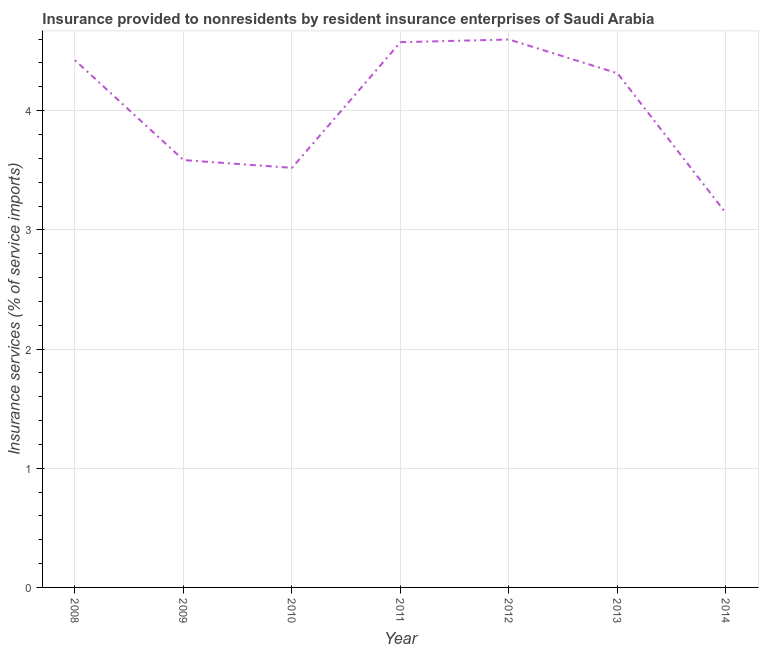What is the insurance and financial services in 2013?
Your answer should be compact. 4.31. Across all years, what is the maximum insurance and financial services?
Offer a very short reply. 4.6. Across all years, what is the minimum insurance and financial services?
Ensure brevity in your answer.  3.14. What is the sum of the insurance and financial services?
Offer a terse response. 28.16. What is the difference between the insurance and financial services in 2011 and 2013?
Your answer should be compact. 0.26. What is the average insurance and financial services per year?
Provide a short and direct response. 4.02. What is the median insurance and financial services?
Your response must be concise. 4.31. In how many years, is the insurance and financial services greater than 1.2 %?
Make the answer very short. 7. Do a majority of the years between 2011 and 2012 (inclusive) have insurance and financial services greater than 3.8 %?
Your answer should be compact. Yes. What is the ratio of the insurance and financial services in 2008 to that in 2009?
Offer a terse response. 1.23. Is the difference between the insurance and financial services in 2008 and 2011 greater than the difference between any two years?
Ensure brevity in your answer.  No. What is the difference between the highest and the second highest insurance and financial services?
Make the answer very short. 0.02. Is the sum of the insurance and financial services in 2011 and 2013 greater than the maximum insurance and financial services across all years?
Ensure brevity in your answer.  Yes. What is the difference between the highest and the lowest insurance and financial services?
Make the answer very short. 1.46. How many years are there in the graph?
Provide a succinct answer. 7. What is the difference between two consecutive major ticks on the Y-axis?
Ensure brevity in your answer.  1. What is the title of the graph?
Offer a very short reply. Insurance provided to nonresidents by resident insurance enterprises of Saudi Arabia. What is the label or title of the X-axis?
Give a very brief answer. Year. What is the label or title of the Y-axis?
Offer a very short reply. Insurance services (% of service imports). What is the Insurance services (% of service imports) in 2008?
Provide a short and direct response. 4.42. What is the Insurance services (% of service imports) in 2009?
Offer a very short reply. 3.59. What is the Insurance services (% of service imports) in 2010?
Keep it short and to the point. 3.52. What is the Insurance services (% of service imports) in 2011?
Offer a very short reply. 4.57. What is the Insurance services (% of service imports) of 2012?
Your response must be concise. 4.6. What is the Insurance services (% of service imports) in 2013?
Provide a succinct answer. 4.31. What is the Insurance services (% of service imports) in 2014?
Ensure brevity in your answer.  3.14. What is the difference between the Insurance services (% of service imports) in 2008 and 2009?
Provide a short and direct response. 0.84. What is the difference between the Insurance services (% of service imports) in 2008 and 2010?
Provide a short and direct response. 0.9. What is the difference between the Insurance services (% of service imports) in 2008 and 2011?
Your answer should be very brief. -0.15. What is the difference between the Insurance services (% of service imports) in 2008 and 2012?
Provide a short and direct response. -0.17. What is the difference between the Insurance services (% of service imports) in 2008 and 2013?
Provide a short and direct response. 0.11. What is the difference between the Insurance services (% of service imports) in 2008 and 2014?
Keep it short and to the point. 1.28. What is the difference between the Insurance services (% of service imports) in 2009 and 2010?
Provide a succinct answer. 0.07. What is the difference between the Insurance services (% of service imports) in 2009 and 2011?
Make the answer very short. -0.99. What is the difference between the Insurance services (% of service imports) in 2009 and 2012?
Offer a very short reply. -1.01. What is the difference between the Insurance services (% of service imports) in 2009 and 2013?
Your answer should be very brief. -0.73. What is the difference between the Insurance services (% of service imports) in 2009 and 2014?
Provide a succinct answer. 0.45. What is the difference between the Insurance services (% of service imports) in 2010 and 2011?
Provide a succinct answer. -1.05. What is the difference between the Insurance services (% of service imports) in 2010 and 2012?
Your response must be concise. -1.08. What is the difference between the Insurance services (% of service imports) in 2010 and 2013?
Your answer should be compact. -0.79. What is the difference between the Insurance services (% of service imports) in 2010 and 2014?
Provide a succinct answer. 0.38. What is the difference between the Insurance services (% of service imports) in 2011 and 2012?
Provide a short and direct response. -0.02. What is the difference between the Insurance services (% of service imports) in 2011 and 2013?
Your response must be concise. 0.26. What is the difference between the Insurance services (% of service imports) in 2011 and 2014?
Your answer should be very brief. 1.43. What is the difference between the Insurance services (% of service imports) in 2012 and 2013?
Your answer should be very brief. 0.28. What is the difference between the Insurance services (% of service imports) in 2012 and 2014?
Keep it short and to the point. 1.46. What is the difference between the Insurance services (% of service imports) in 2013 and 2014?
Offer a terse response. 1.17. What is the ratio of the Insurance services (% of service imports) in 2008 to that in 2009?
Your response must be concise. 1.23. What is the ratio of the Insurance services (% of service imports) in 2008 to that in 2010?
Give a very brief answer. 1.26. What is the ratio of the Insurance services (% of service imports) in 2008 to that in 2011?
Your response must be concise. 0.97. What is the ratio of the Insurance services (% of service imports) in 2008 to that in 2014?
Keep it short and to the point. 1.41. What is the ratio of the Insurance services (% of service imports) in 2009 to that in 2010?
Make the answer very short. 1.02. What is the ratio of the Insurance services (% of service imports) in 2009 to that in 2011?
Ensure brevity in your answer.  0.78. What is the ratio of the Insurance services (% of service imports) in 2009 to that in 2012?
Provide a short and direct response. 0.78. What is the ratio of the Insurance services (% of service imports) in 2009 to that in 2013?
Your answer should be compact. 0.83. What is the ratio of the Insurance services (% of service imports) in 2009 to that in 2014?
Offer a terse response. 1.14. What is the ratio of the Insurance services (% of service imports) in 2010 to that in 2011?
Offer a terse response. 0.77. What is the ratio of the Insurance services (% of service imports) in 2010 to that in 2012?
Give a very brief answer. 0.77. What is the ratio of the Insurance services (% of service imports) in 2010 to that in 2013?
Offer a terse response. 0.82. What is the ratio of the Insurance services (% of service imports) in 2010 to that in 2014?
Keep it short and to the point. 1.12. What is the ratio of the Insurance services (% of service imports) in 2011 to that in 2013?
Provide a short and direct response. 1.06. What is the ratio of the Insurance services (% of service imports) in 2011 to that in 2014?
Ensure brevity in your answer.  1.46. What is the ratio of the Insurance services (% of service imports) in 2012 to that in 2013?
Ensure brevity in your answer.  1.07. What is the ratio of the Insurance services (% of service imports) in 2012 to that in 2014?
Keep it short and to the point. 1.46. What is the ratio of the Insurance services (% of service imports) in 2013 to that in 2014?
Offer a terse response. 1.37. 